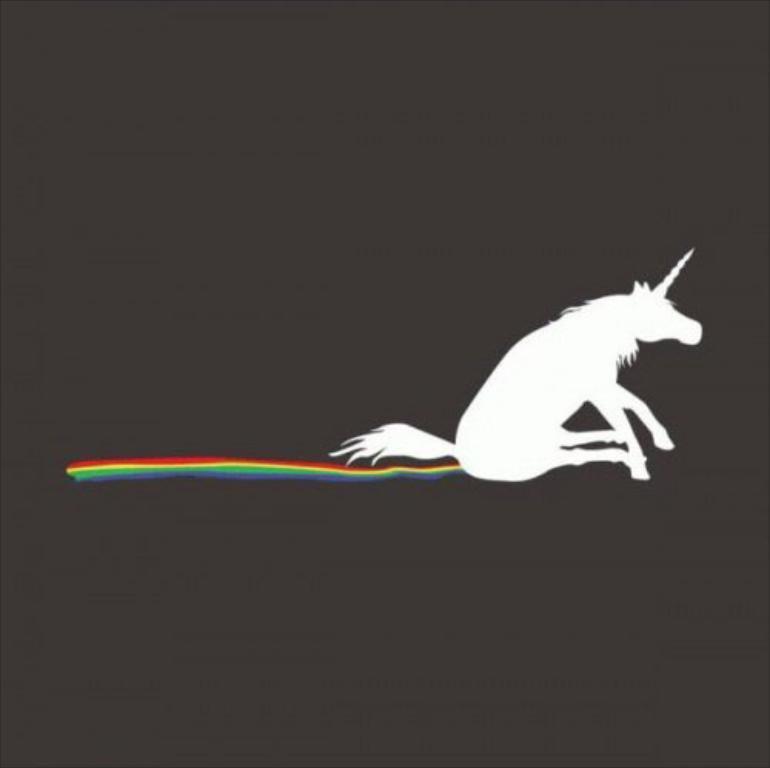Please provide a concise description of this image. This is an edited image of a unicorn and different colors and behind the unicorn there is a dark background. 